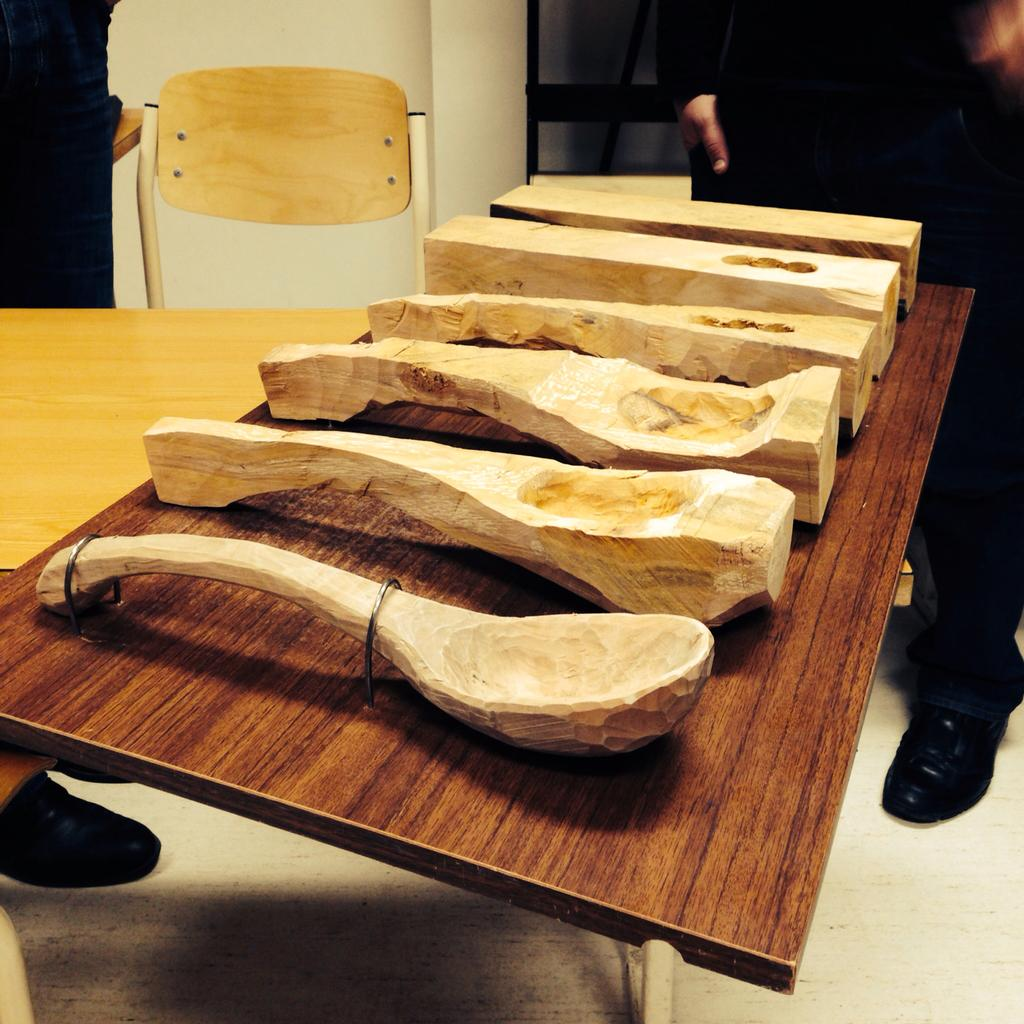What objects are present in the image? There are pieces of wood in the image. Where are the pieces of wood located? The pieces of wood are placed on a table. What type of brake can be seen on the wood in the image? There is no brake present in the image; it features pieces of wood placed on a table. What kind of rock is visible in the image? There is no rock present in the image; it features pieces of wood placed on a table. 